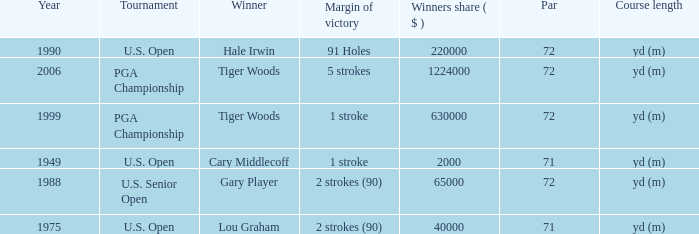When gary player is the winner what is the lowest winners share in dollars? 65000.0. 